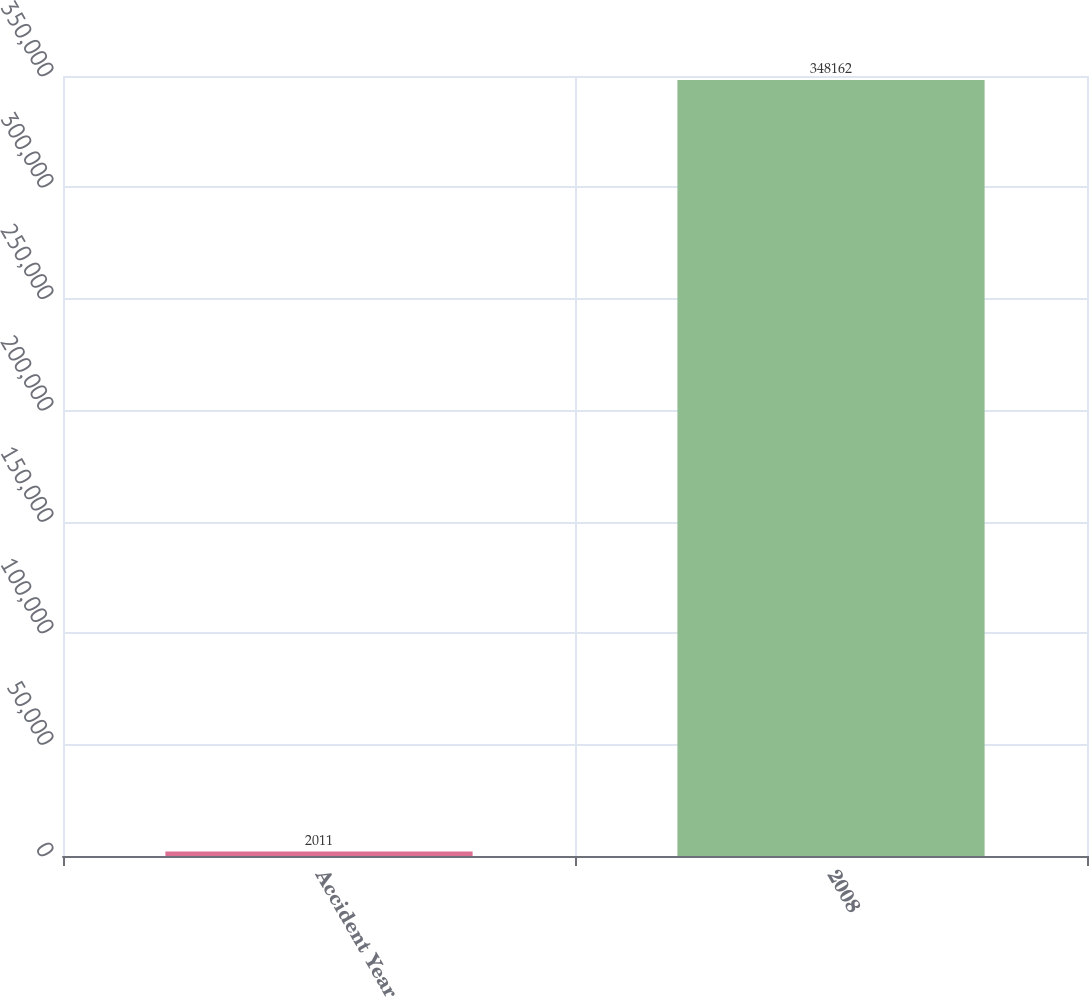<chart> <loc_0><loc_0><loc_500><loc_500><bar_chart><fcel>Accident Year<fcel>2008<nl><fcel>2011<fcel>348162<nl></chart> 